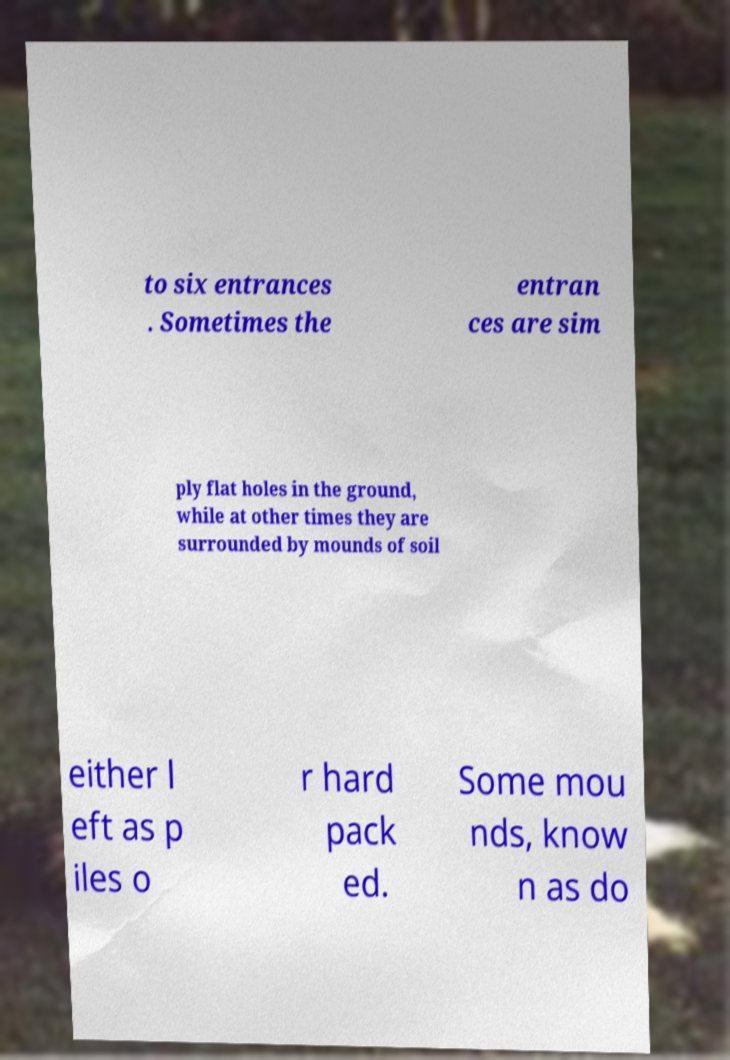What messages or text are displayed in this image? I need them in a readable, typed format. to six entrances . Sometimes the entran ces are sim ply flat holes in the ground, while at other times they are surrounded by mounds of soil either l eft as p iles o r hard pack ed. Some mou nds, know n as do 